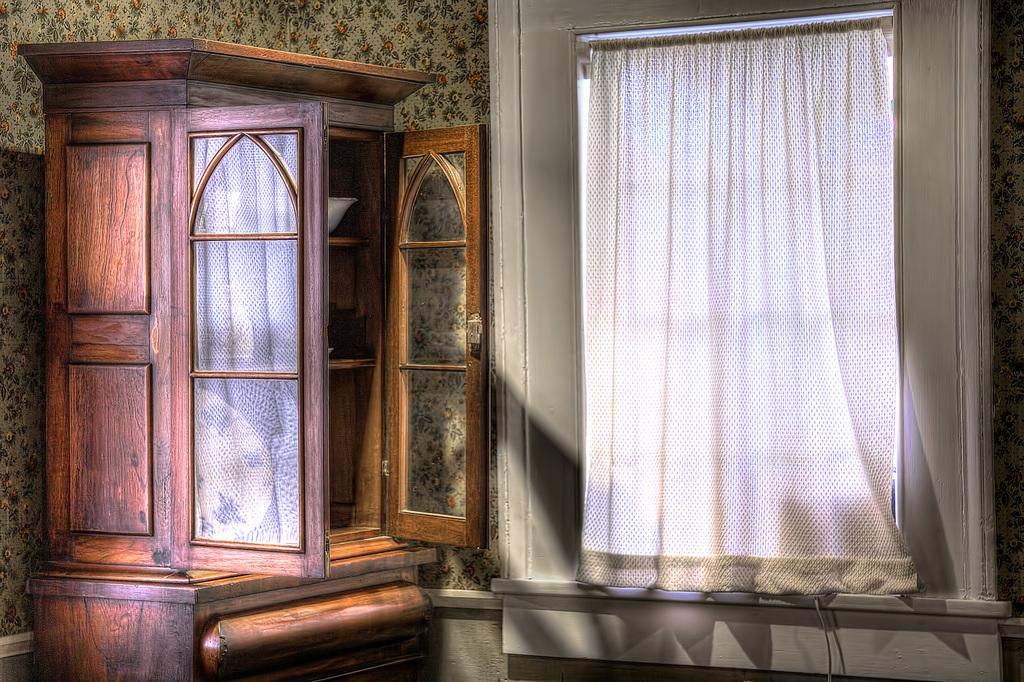What type of furniture is present in the image? There is a cupboard in the image. What is the color of the cupboard? The cupboard is brown in color. What can be seen on the other side of the cupboard in the image? There is a wall in the image. What is the color of the wall? The wall is white in color. What type of window treatment is present in the image? There is a curtain in the image. What is the color of the curtain? The curtain is white in color. What else is visible in the image besides the cupboard, wall, and curtain? There is a wire visible in the image. How many cherries are hanging from the wire in the image? There are no cherries present in the image; only a wire is visible. What grade does the wall receive for its cleanliness in the image? The image does not provide any information about the cleanliness of the wall, nor does it assign grades to objects in the image. 